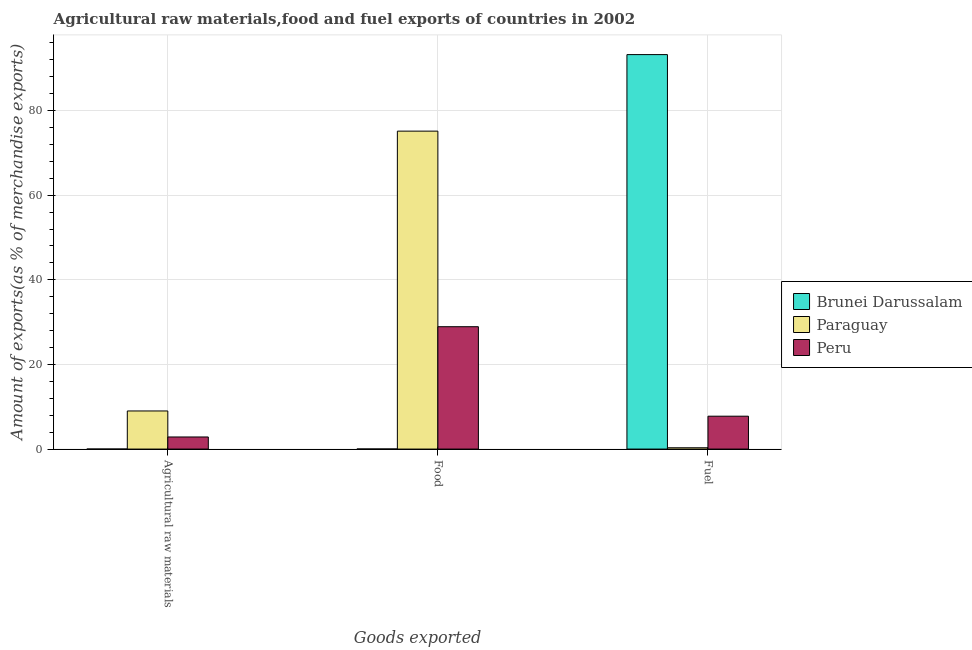Are the number of bars per tick equal to the number of legend labels?
Your answer should be very brief. Yes. Are the number of bars on each tick of the X-axis equal?
Provide a succinct answer. Yes. How many bars are there on the 1st tick from the left?
Your answer should be very brief. 3. How many bars are there on the 3rd tick from the right?
Ensure brevity in your answer.  3. What is the label of the 1st group of bars from the left?
Make the answer very short. Agricultural raw materials. What is the percentage of food exports in Brunei Darussalam?
Your answer should be very brief. 0.02. Across all countries, what is the maximum percentage of raw materials exports?
Your answer should be compact. 9.01. Across all countries, what is the minimum percentage of food exports?
Make the answer very short. 0.02. In which country was the percentage of food exports maximum?
Your answer should be compact. Paraguay. In which country was the percentage of fuel exports minimum?
Offer a terse response. Paraguay. What is the total percentage of food exports in the graph?
Ensure brevity in your answer.  104.08. What is the difference between the percentage of food exports in Paraguay and that in Brunei Darussalam?
Your answer should be compact. 75.12. What is the difference between the percentage of food exports in Paraguay and the percentage of fuel exports in Peru?
Give a very brief answer. 67.37. What is the average percentage of raw materials exports per country?
Offer a very short reply. 3.96. What is the difference between the percentage of fuel exports and percentage of raw materials exports in Brunei Darussalam?
Make the answer very short. 93.22. What is the ratio of the percentage of food exports in Brunei Darussalam to that in Paraguay?
Provide a succinct answer. 0. Is the percentage of food exports in Peru less than that in Paraguay?
Your answer should be compact. Yes. What is the difference between the highest and the second highest percentage of fuel exports?
Provide a succinct answer. 85.46. What is the difference between the highest and the lowest percentage of food exports?
Make the answer very short. 75.12. In how many countries, is the percentage of food exports greater than the average percentage of food exports taken over all countries?
Provide a succinct answer. 1. What does the 2nd bar from the left in Agricultural raw materials represents?
Give a very brief answer. Paraguay. What does the 2nd bar from the right in Fuel represents?
Your response must be concise. Paraguay. Is it the case that in every country, the sum of the percentage of raw materials exports and percentage of food exports is greater than the percentage of fuel exports?
Ensure brevity in your answer.  No. How many bars are there?
Provide a succinct answer. 9. Are all the bars in the graph horizontal?
Offer a terse response. No. How many countries are there in the graph?
Provide a succinct answer. 3. Where does the legend appear in the graph?
Provide a short and direct response. Center right. What is the title of the graph?
Keep it short and to the point. Agricultural raw materials,food and fuel exports of countries in 2002. Does "Latin America(developing only)" appear as one of the legend labels in the graph?
Offer a terse response. No. What is the label or title of the X-axis?
Your response must be concise. Goods exported. What is the label or title of the Y-axis?
Offer a terse response. Amount of exports(as % of merchandise exports). What is the Amount of exports(as % of merchandise exports) of Brunei Darussalam in Agricultural raw materials?
Provide a short and direct response. 0.01. What is the Amount of exports(as % of merchandise exports) in Paraguay in Agricultural raw materials?
Make the answer very short. 9.01. What is the Amount of exports(as % of merchandise exports) of Peru in Agricultural raw materials?
Offer a very short reply. 2.86. What is the Amount of exports(as % of merchandise exports) in Brunei Darussalam in Food?
Ensure brevity in your answer.  0.02. What is the Amount of exports(as % of merchandise exports) of Paraguay in Food?
Ensure brevity in your answer.  75.14. What is the Amount of exports(as % of merchandise exports) in Peru in Food?
Your answer should be very brief. 28.92. What is the Amount of exports(as % of merchandise exports) of Brunei Darussalam in Fuel?
Offer a terse response. 93.23. What is the Amount of exports(as % of merchandise exports) of Paraguay in Fuel?
Ensure brevity in your answer.  0.31. What is the Amount of exports(as % of merchandise exports) in Peru in Fuel?
Offer a very short reply. 7.77. Across all Goods exported, what is the maximum Amount of exports(as % of merchandise exports) of Brunei Darussalam?
Keep it short and to the point. 93.23. Across all Goods exported, what is the maximum Amount of exports(as % of merchandise exports) of Paraguay?
Provide a succinct answer. 75.14. Across all Goods exported, what is the maximum Amount of exports(as % of merchandise exports) in Peru?
Ensure brevity in your answer.  28.92. Across all Goods exported, what is the minimum Amount of exports(as % of merchandise exports) of Brunei Darussalam?
Offer a terse response. 0.01. Across all Goods exported, what is the minimum Amount of exports(as % of merchandise exports) of Paraguay?
Keep it short and to the point. 0.31. Across all Goods exported, what is the minimum Amount of exports(as % of merchandise exports) of Peru?
Your answer should be very brief. 2.86. What is the total Amount of exports(as % of merchandise exports) of Brunei Darussalam in the graph?
Provide a short and direct response. 93.25. What is the total Amount of exports(as % of merchandise exports) in Paraguay in the graph?
Your response must be concise. 84.45. What is the total Amount of exports(as % of merchandise exports) in Peru in the graph?
Provide a succinct answer. 39.55. What is the difference between the Amount of exports(as % of merchandise exports) in Brunei Darussalam in Agricultural raw materials and that in Food?
Your answer should be very brief. -0.02. What is the difference between the Amount of exports(as % of merchandise exports) of Paraguay in Agricultural raw materials and that in Food?
Your response must be concise. -66.13. What is the difference between the Amount of exports(as % of merchandise exports) of Peru in Agricultural raw materials and that in Food?
Give a very brief answer. -26.06. What is the difference between the Amount of exports(as % of merchandise exports) of Brunei Darussalam in Agricultural raw materials and that in Fuel?
Ensure brevity in your answer.  -93.22. What is the difference between the Amount of exports(as % of merchandise exports) in Paraguay in Agricultural raw materials and that in Fuel?
Offer a very short reply. 8.7. What is the difference between the Amount of exports(as % of merchandise exports) in Peru in Agricultural raw materials and that in Fuel?
Keep it short and to the point. -4.91. What is the difference between the Amount of exports(as % of merchandise exports) in Brunei Darussalam in Food and that in Fuel?
Offer a terse response. -93.21. What is the difference between the Amount of exports(as % of merchandise exports) of Paraguay in Food and that in Fuel?
Make the answer very short. 74.83. What is the difference between the Amount of exports(as % of merchandise exports) of Peru in Food and that in Fuel?
Offer a terse response. 21.15. What is the difference between the Amount of exports(as % of merchandise exports) of Brunei Darussalam in Agricultural raw materials and the Amount of exports(as % of merchandise exports) of Paraguay in Food?
Your answer should be very brief. -75.13. What is the difference between the Amount of exports(as % of merchandise exports) in Brunei Darussalam in Agricultural raw materials and the Amount of exports(as % of merchandise exports) in Peru in Food?
Offer a terse response. -28.91. What is the difference between the Amount of exports(as % of merchandise exports) in Paraguay in Agricultural raw materials and the Amount of exports(as % of merchandise exports) in Peru in Food?
Your answer should be compact. -19.91. What is the difference between the Amount of exports(as % of merchandise exports) of Brunei Darussalam in Agricultural raw materials and the Amount of exports(as % of merchandise exports) of Paraguay in Fuel?
Your answer should be very brief. -0.3. What is the difference between the Amount of exports(as % of merchandise exports) of Brunei Darussalam in Agricultural raw materials and the Amount of exports(as % of merchandise exports) of Peru in Fuel?
Your response must be concise. -7.76. What is the difference between the Amount of exports(as % of merchandise exports) of Paraguay in Agricultural raw materials and the Amount of exports(as % of merchandise exports) of Peru in Fuel?
Your response must be concise. 1.24. What is the difference between the Amount of exports(as % of merchandise exports) in Brunei Darussalam in Food and the Amount of exports(as % of merchandise exports) in Paraguay in Fuel?
Provide a short and direct response. -0.29. What is the difference between the Amount of exports(as % of merchandise exports) in Brunei Darussalam in Food and the Amount of exports(as % of merchandise exports) in Peru in Fuel?
Offer a very short reply. -7.75. What is the difference between the Amount of exports(as % of merchandise exports) of Paraguay in Food and the Amount of exports(as % of merchandise exports) of Peru in Fuel?
Your answer should be very brief. 67.37. What is the average Amount of exports(as % of merchandise exports) in Brunei Darussalam per Goods exported?
Keep it short and to the point. 31.08. What is the average Amount of exports(as % of merchandise exports) of Paraguay per Goods exported?
Offer a very short reply. 28.15. What is the average Amount of exports(as % of merchandise exports) of Peru per Goods exported?
Ensure brevity in your answer.  13.18. What is the difference between the Amount of exports(as % of merchandise exports) of Brunei Darussalam and Amount of exports(as % of merchandise exports) of Paraguay in Agricultural raw materials?
Give a very brief answer. -9. What is the difference between the Amount of exports(as % of merchandise exports) in Brunei Darussalam and Amount of exports(as % of merchandise exports) in Peru in Agricultural raw materials?
Provide a short and direct response. -2.86. What is the difference between the Amount of exports(as % of merchandise exports) of Paraguay and Amount of exports(as % of merchandise exports) of Peru in Agricultural raw materials?
Give a very brief answer. 6.15. What is the difference between the Amount of exports(as % of merchandise exports) of Brunei Darussalam and Amount of exports(as % of merchandise exports) of Paraguay in Food?
Offer a very short reply. -75.12. What is the difference between the Amount of exports(as % of merchandise exports) in Brunei Darussalam and Amount of exports(as % of merchandise exports) in Peru in Food?
Give a very brief answer. -28.9. What is the difference between the Amount of exports(as % of merchandise exports) of Paraguay and Amount of exports(as % of merchandise exports) of Peru in Food?
Your answer should be very brief. 46.22. What is the difference between the Amount of exports(as % of merchandise exports) in Brunei Darussalam and Amount of exports(as % of merchandise exports) in Paraguay in Fuel?
Give a very brief answer. 92.92. What is the difference between the Amount of exports(as % of merchandise exports) of Brunei Darussalam and Amount of exports(as % of merchandise exports) of Peru in Fuel?
Provide a short and direct response. 85.46. What is the difference between the Amount of exports(as % of merchandise exports) of Paraguay and Amount of exports(as % of merchandise exports) of Peru in Fuel?
Your answer should be very brief. -7.46. What is the ratio of the Amount of exports(as % of merchandise exports) in Brunei Darussalam in Agricultural raw materials to that in Food?
Make the answer very short. 0.25. What is the ratio of the Amount of exports(as % of merchandise exports) of Paraguay in Agricultural raw materials to that in Food?
Your response must be concise. 0.12. What is the ratio of the Amount of exports(as % of merchandise exports) in Peru in Agricultural raw materials to that in Food?
Your answer should be very brief. 0.1. What is the ratio of the Amount of exports(as % of merchandise exports) in Brunei Darussalam in Agricultural raw materials to that in Fuel?
Provide a succinct answer. 0. What is the ratio of the Amount of exports(as % of merchandise exports) of Paraguay in Agricultural raw materials to that in Fuel?
Ensure brevity in your answer.  29.05. What is the ratio of the Amount of exports(as % of merchandise exports) in Peru in Agricultural raw materials to that in Fuel?
Provide a succinct answer. 0.37. What is the ratio of the Amount of exports(as % of merchandise exports) of Paraguay in Food to that in Fuel?
Your answer should be very brief. 242.32. What is the ratio of the Amount of exports(as % of merchandise exports) in Peru in Food to that in Fuel?
Your answer should be very brief. 3.72. What is the difference between the highest and the second highest Amount of exports(as % of merchandise exports) in Brunei Darussalam?
Offer a terse response. 93.21. What is the difference between the highest and the second highest Amount of exports(as % of merchandise exports) of Paraguay?
Offer a very short reply. 66.13. What is the difference between the highest and the second highest Amount of exports(as % of merchandise exports) in Peru?
Offer a very short reply. 21.15. What is the difference between the highest and the lowest Amount of exports(as % of merchandise exports) of Brunei Darussalam?
Provide a succinct answer. 93.22. What is the difference between the highest and the lowest Amount of exports(as % of merchandise exports) in Paraguay?
Your response must be concise. 74.83. What is the difference between the highest and the lowest Amount of exports(as % of merchandise exports) in Peru?
Your answer should be very brief. 26.06. 